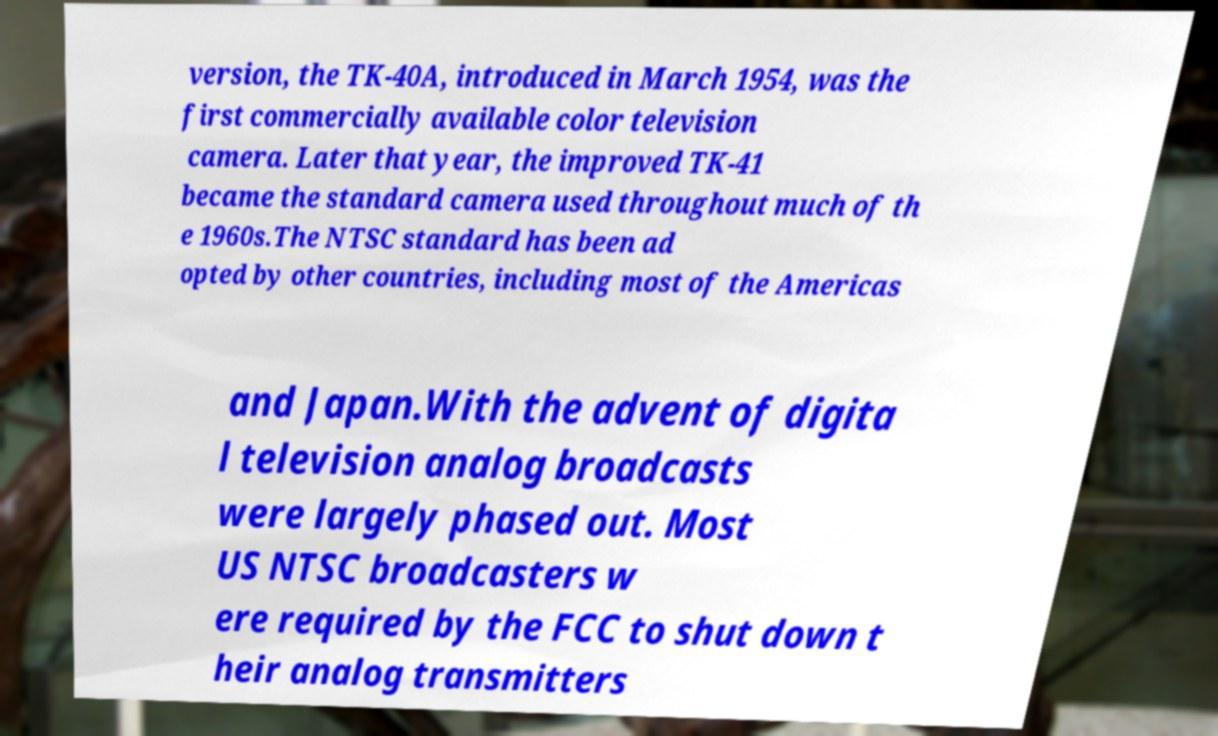What messages or text are displayed in this image? I need them in a readable, typed format. version, the TK-40A, introduced in March 1954, was the first commercially available color television camera. Later that year, the improved TK-41 became the standard camera used throughout much of th e 1960s.The NTSC standard has been ad opted by other countries, including most of the Americas and Japan.With the advent of digita l television analog broadcasts were largely phased out. Most US NTSC broadcasters w ere required by the FCC to shut down t heir analog transmitters 